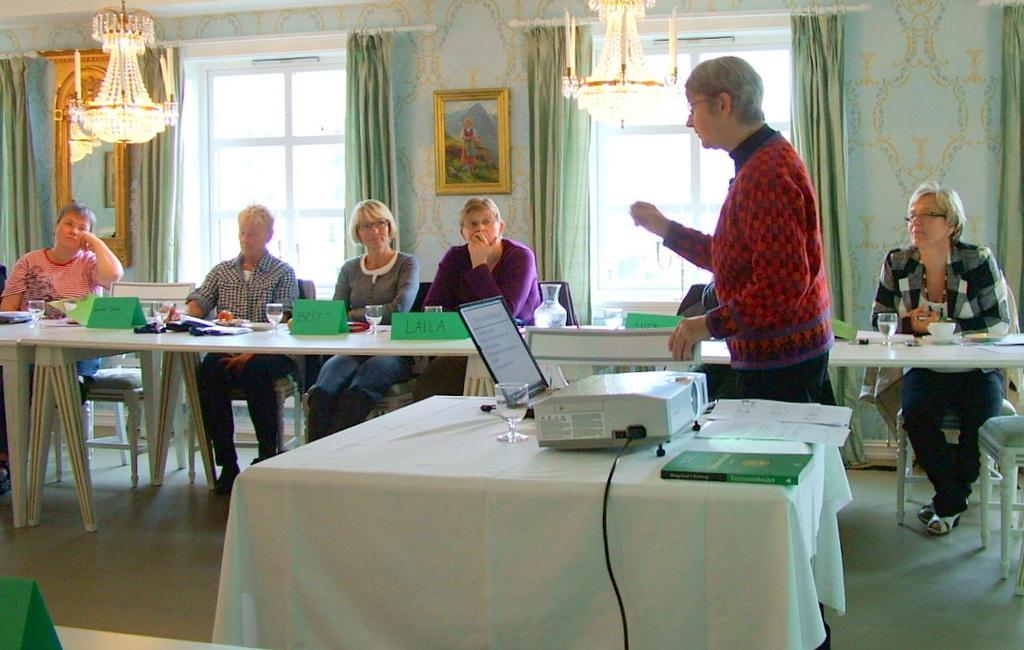Describe this image in one or two sentences. On the background we can see decorative wall, photo frame over it. These are windows and curtains in green colour. These are ceiling lights. Here we can see few persons sitting on chairs in front of a table and on the table we can see glasses, boards, cup and saucer. Here in front of the picture we can see a table and on the table we can see projector device, books , laptop and a glass of water. Here we can see one man standing near to this table. 